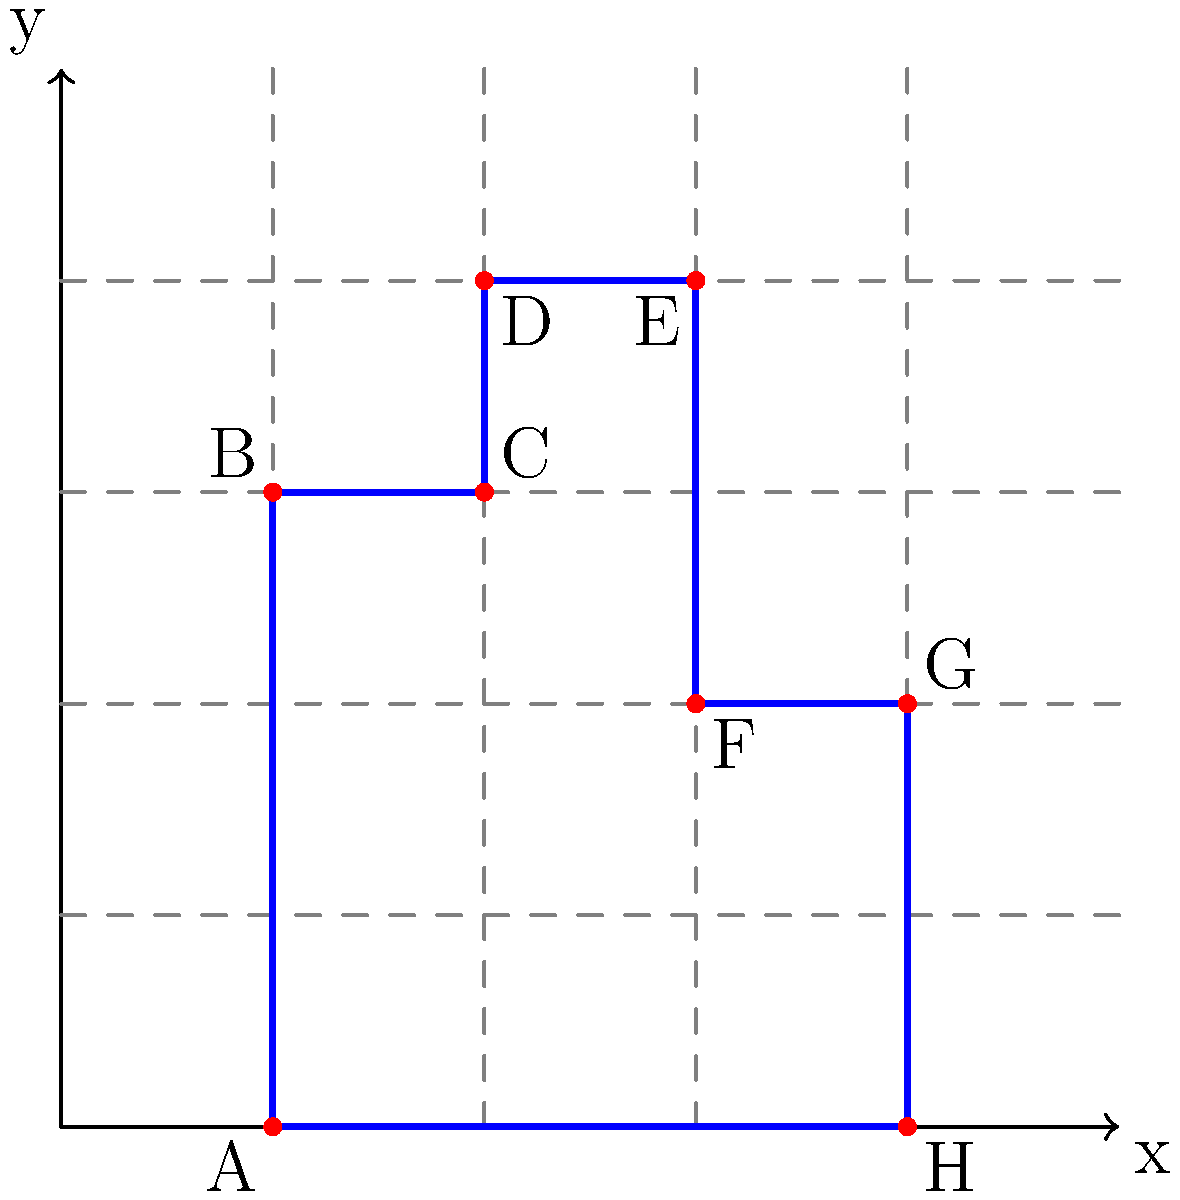You're designing a LEGO Stark Tower with your child, and you've created this coordinate blueprint. What are the coordinates of point D, which represents the highest point of the left section of the tower? Let's approach this step-by-step:

1. First, we need to understand how to read coordinates from the graph. The coordinates are in the form (x, y), where x is the horizontal distance from the origin, and y is the vertical distance.

2. We're looking for point D, which is labeled on the graph.

3. To find the x-coordinate of point D:
   - Count the number of units from the y-axis to point D.
   - We can see that D is 4 units to the right of the y-axis.

4. To find the y-coordinate of point D:
   - Count the number of units from the x-axis up to point D.
   - We can see that D is 8 units above the x-axis.

5. Therefore, the coordinates of point D are (4, 8).

This point represents the highest point of the left section of your LEGO Stark Tower design.
Answer: (4, 8) 